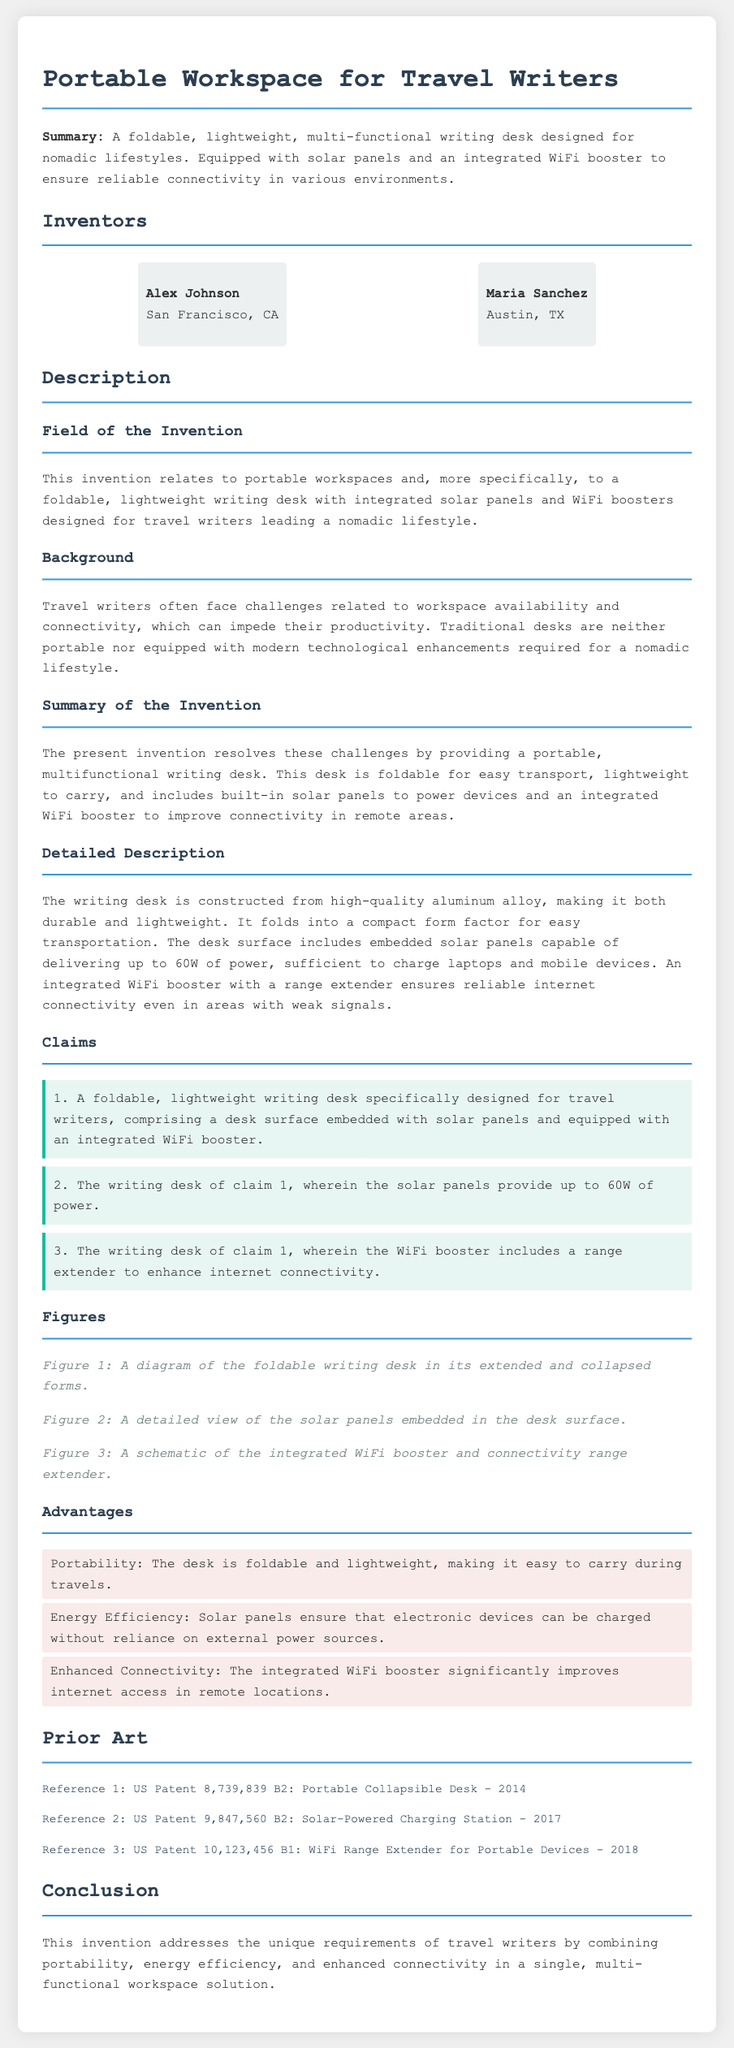What is the title of the patent application? The title of the patent application is stated at the top of the document.
Answer: Portable Workspace for Travel Writers Who are the inventors? The inventors are listed under the "Inventors" section of the document.
Answer: Alex Johnson and Maria Sanchez What material is the writing desk made of? The material of the writing desk is described in the "Detailed Description" section.
Answer: High-quality aluminum alloy How much power do the solar panels provide? The power output of the solar panels is specified in the "Detailed Description" section of the document.
Answer: Up to 60W What are the two main features of the writing desk? The main features are detailed in the "Summary of the Invention" section.
Answer: Solar panels and integrated WiFi booster What advantage does solar efficiency provide? The advantages are listed in the "Advantages" section along with their benefits.
Answer: Energy Efficiency What is the document type of this text? The document type is indicated by its title and structure.
Answer: Patent application How does the writing desk assist travel writers? The assistance provided is summarized in the "Conclusion" section of the document.
Answer: Addresses unique requirements of travel writers 